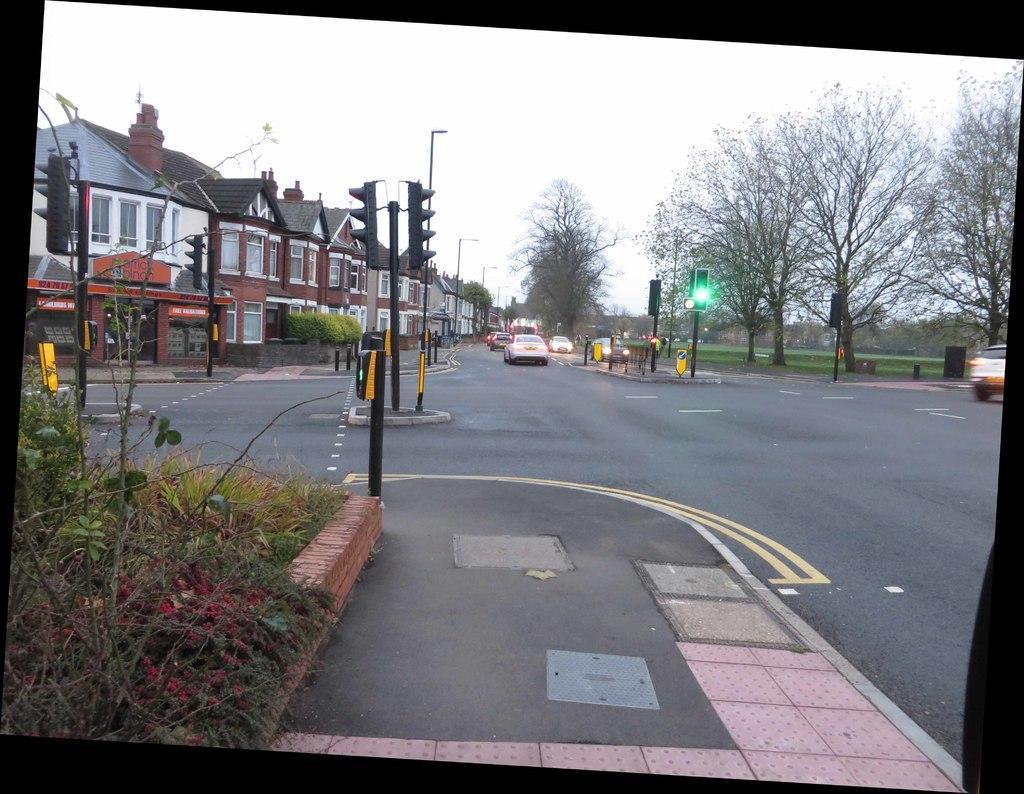Can you describe this image briefly? In front of the image there is a pavement, beside the pavement there are plants, in front of the image there are traffic lights, trees, sign boards, lamp posts and there are cars passing on the roads, beside the road there are houses. 